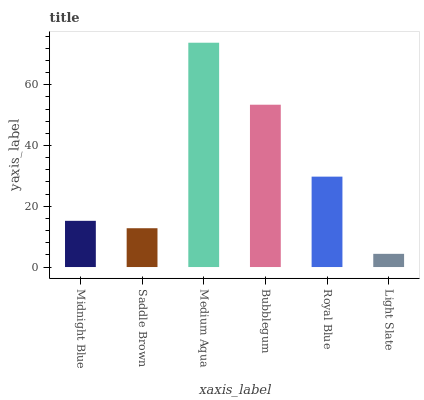Is Light Slate the minimum?
Answer yes or no. Yes. Is Medium Aqua the maximum?
Answer yes or no. Yes. Is Saddle Brown the minimum?
Answer yes or no. No. Is Saddle Brown the maximum?
Answer yes or no. No. Is Midnight Blue greater than Saddle Brown?
Answer yes or no. Yes. Is Saddle Brown less than Midnight Blue?
Answer yes or no. Yes. Is Saddle Brown greater than Midnight Blue?
Answer yes or no. No. Is Midnight Blue less than Saddle Brown?
Answer yes or no. No. Is Royal Blue the high median?
Answer yes or no. Yes. Is Midnight Blue the low median?
Answer yes or no. Yes. Is Light Slate the high median?
Answer yes or no. No. Is Light Slate the low median?
Answer yes or no. No. 